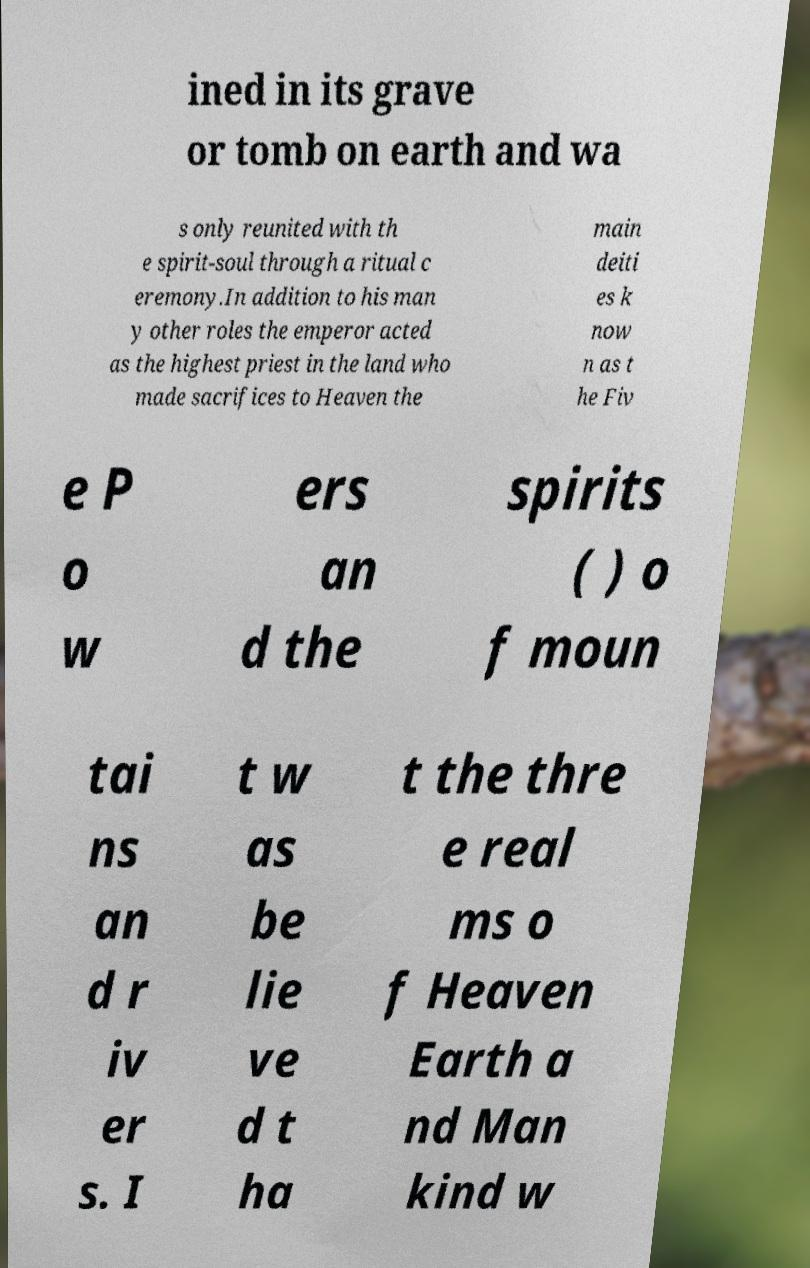For documentation purposes, I need the text within this image transcribed. Could you provide that? ined in its grave or tomb on earth and wa s only reunited with th e spirit-soul through a ritual c eremony.In addition to his man y other roles the emperor acted as the highest priest in the land who made sacrifices to Heaven the main deiti es k now n as t he Fiv e P o w ers an d the spirits ( ) o f moun tai ns an d r iv er s. I t w as be lie ve d t ha t the thre e real ms o f Heaven Earth a nd Man kind w 